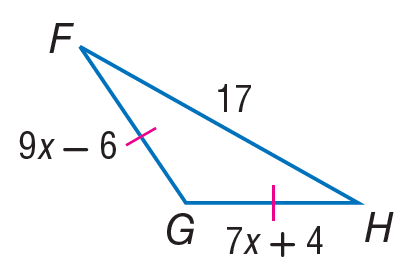Question: Find the length of F G.
Choices:
A. 17
B. 35
C. 39
D. 45
Answer with the letter. Answer: C Question: Find x.
Choices:
A. 4
B. 5
C. 7
D. 17
Answer with the letter. Answer: B Question: Find G H.
Choices:
A. 17
B. 35
C. 39
D. 45
Answer with the letter. Answer: C 